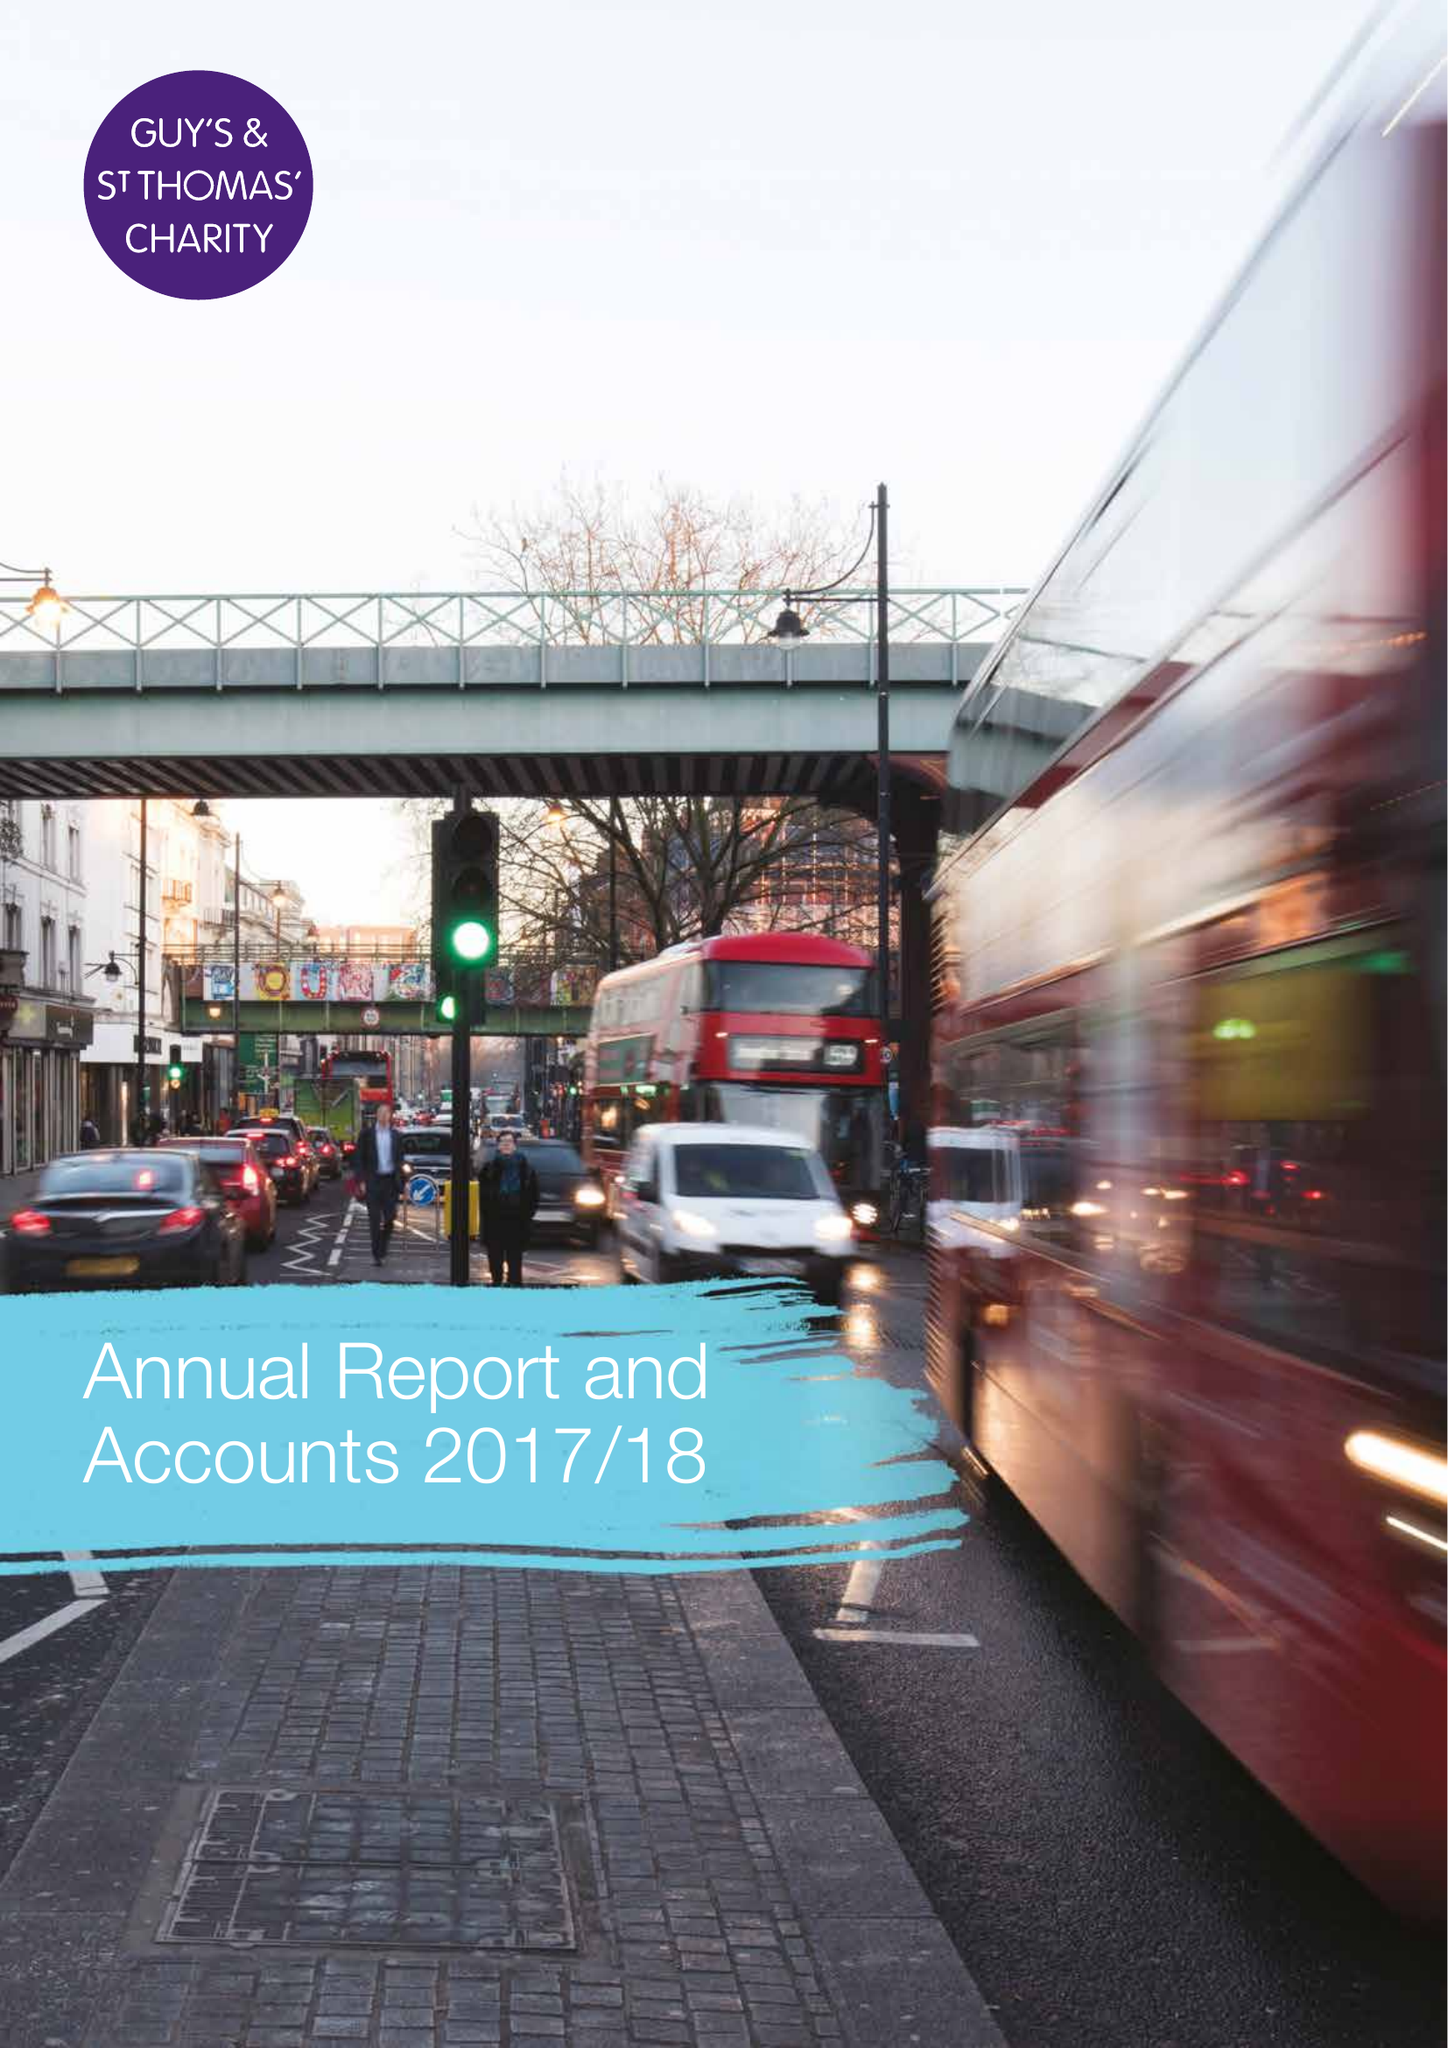What is the value for the income_annually_in_british_pounds?
Answer the question using a single word or phrase. 27065000.00 